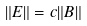<formula> <loc_0><loc_0><loc_500><loc_500>\| { E } \| = c \| { B } \|</formula> 